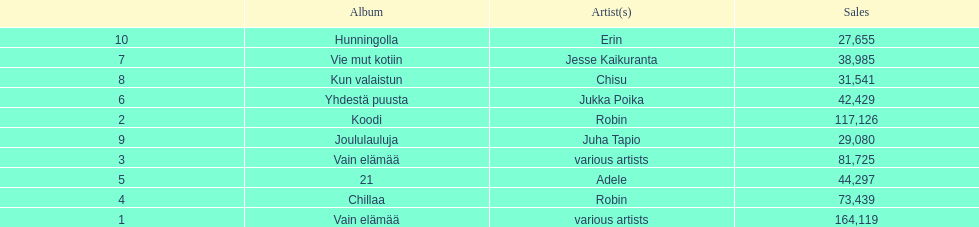Which album had the least amount of sales? Hunningolla. 